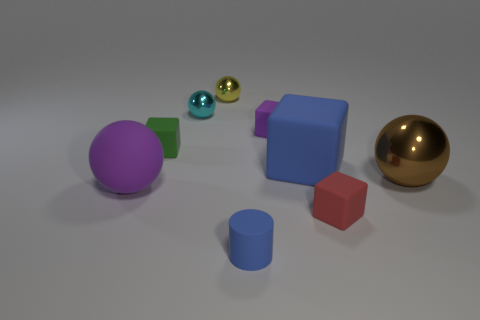Subtract 1 balls. How many balls are left? 3 Add 1 brown cylinders. How many objects exist? 10 Subtract all balls. How many objects are left? 5 Add 8 small cyan objects. How many small cyan objects are left? 9 Add 7 brown shiny spheres. How many brown shiny spheres exist? 8 Subtract 1 purple cubes. How many objects are left? 8 Subtract all yellow things. Subtract all small blue objects. How many objects are left? 7 